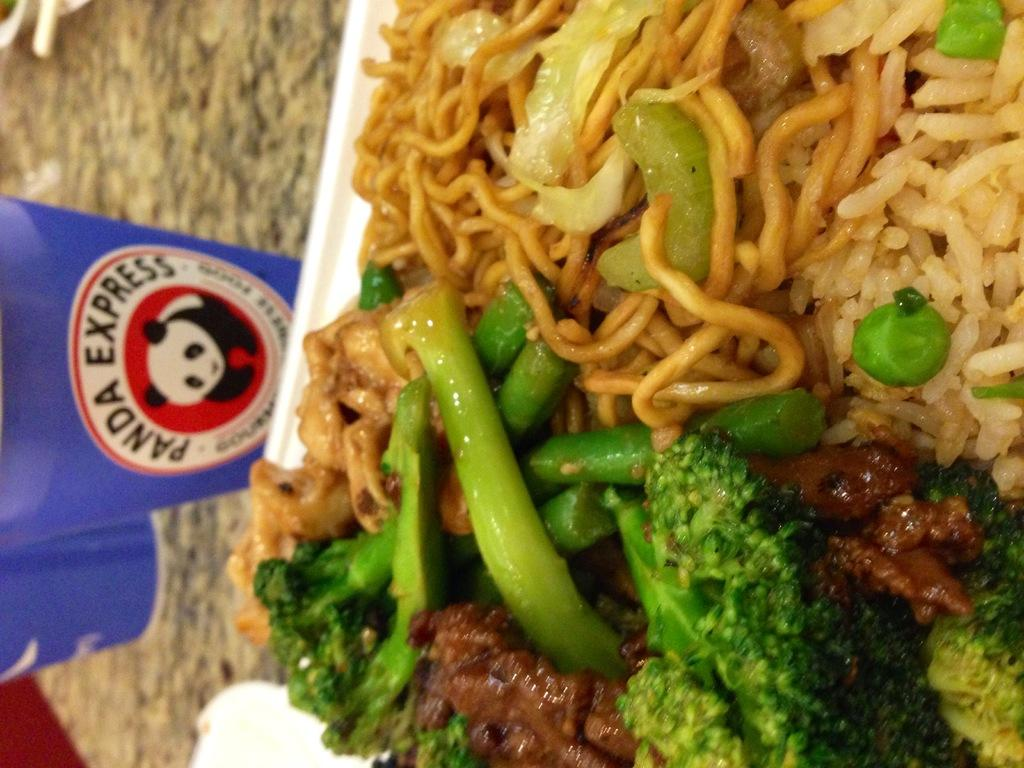What is on the plate that is visible in the image? There is food on a plate in the image. Where is the plate located in the image? The plate is on the right side of the image. How many glasses can be seen in the image? There are two glasses in the image. Where are the glasses located in the image? The glasses are on the left side of the image. What type of amusement can be seen in the image? There is no amusement present in the image; it features a plate with food and two glasses. Is there any wire visible in the image? There is no wire present in the image. 